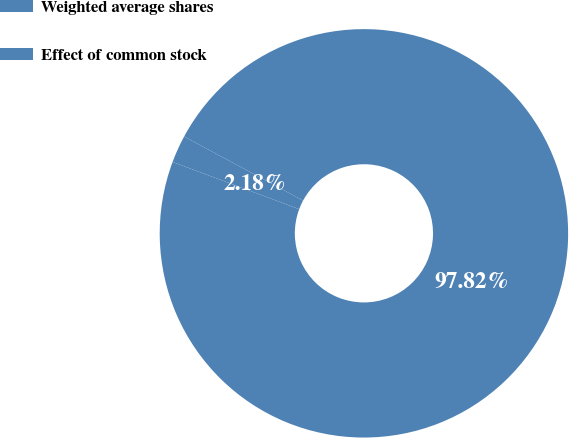<chart> <loc_0><loc_0><loc_500><loc_500><pie_chart><fcel>Weighted average shares<fcel>Effect of common stock<nl><fcel>97.82%<fcel>2.18%<nl></chart> 